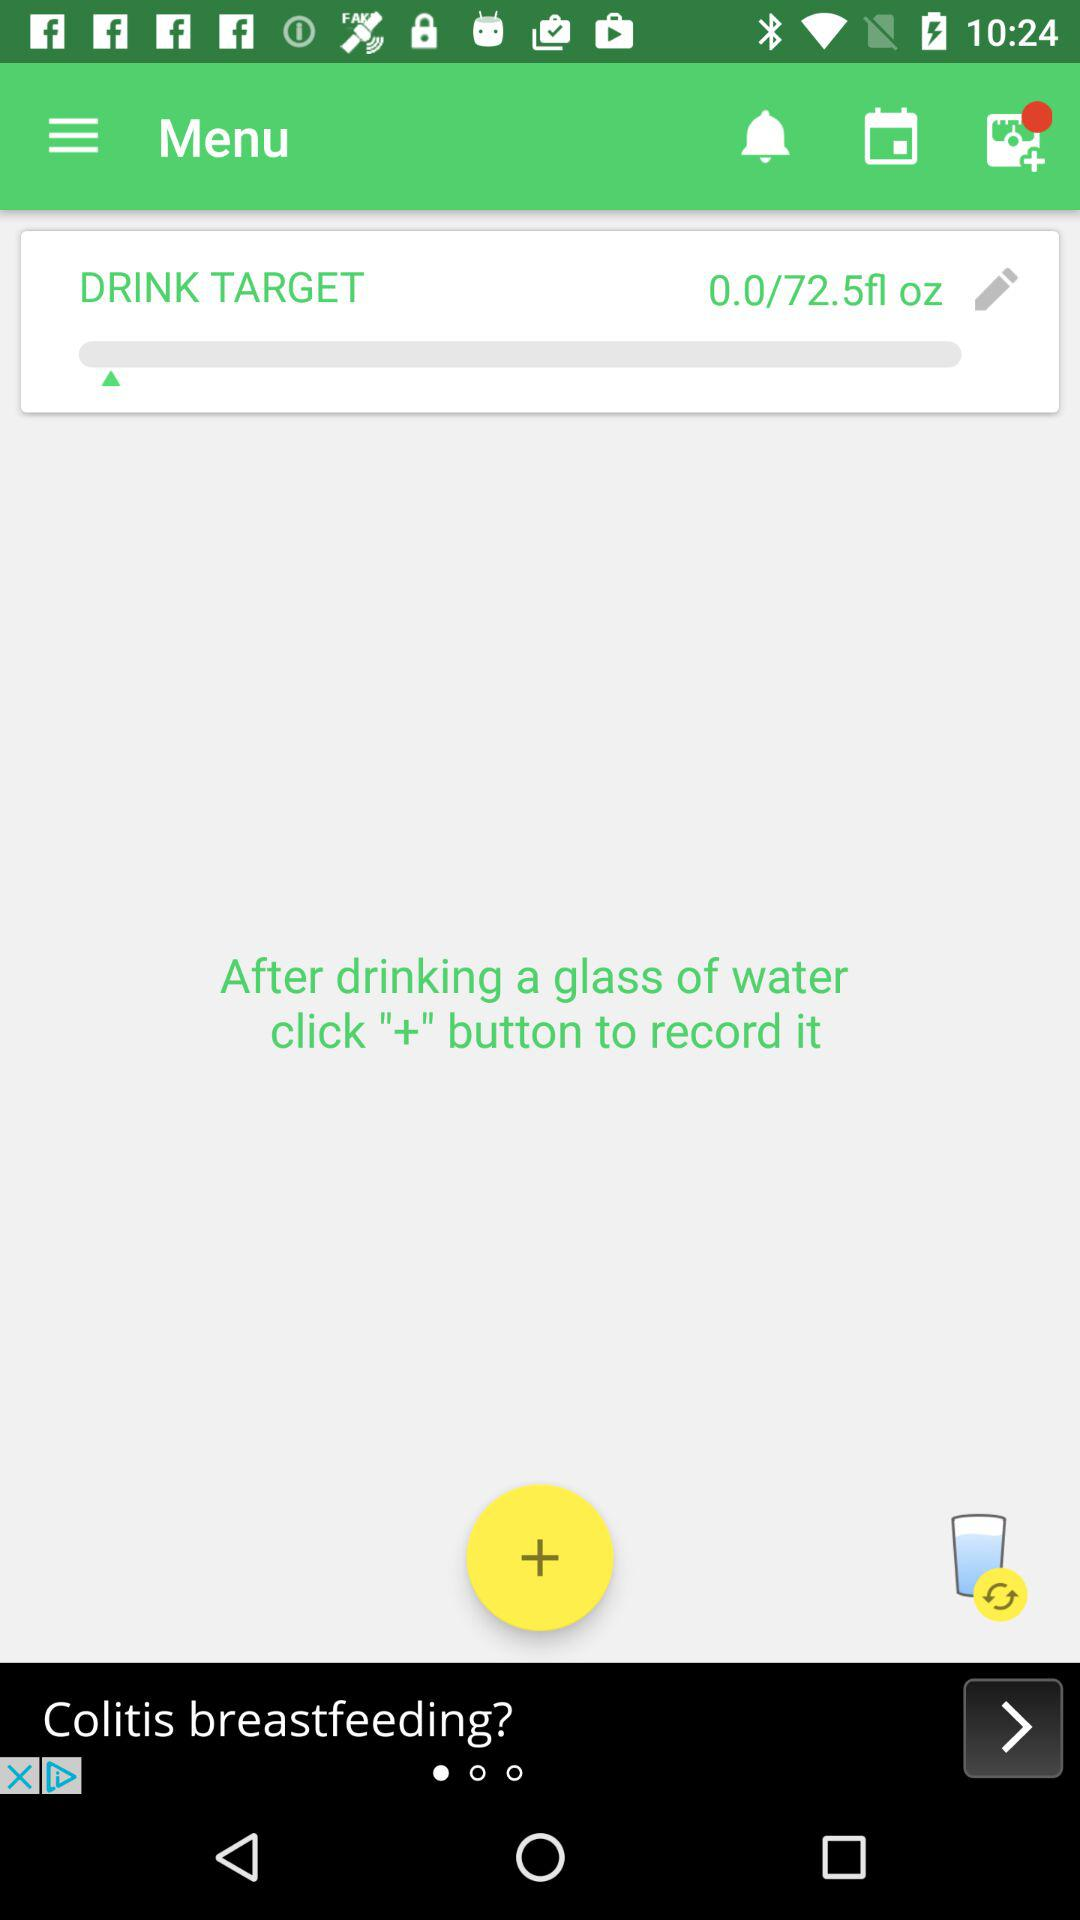Which button has to be pressed to record? To record, press the "+" button. 